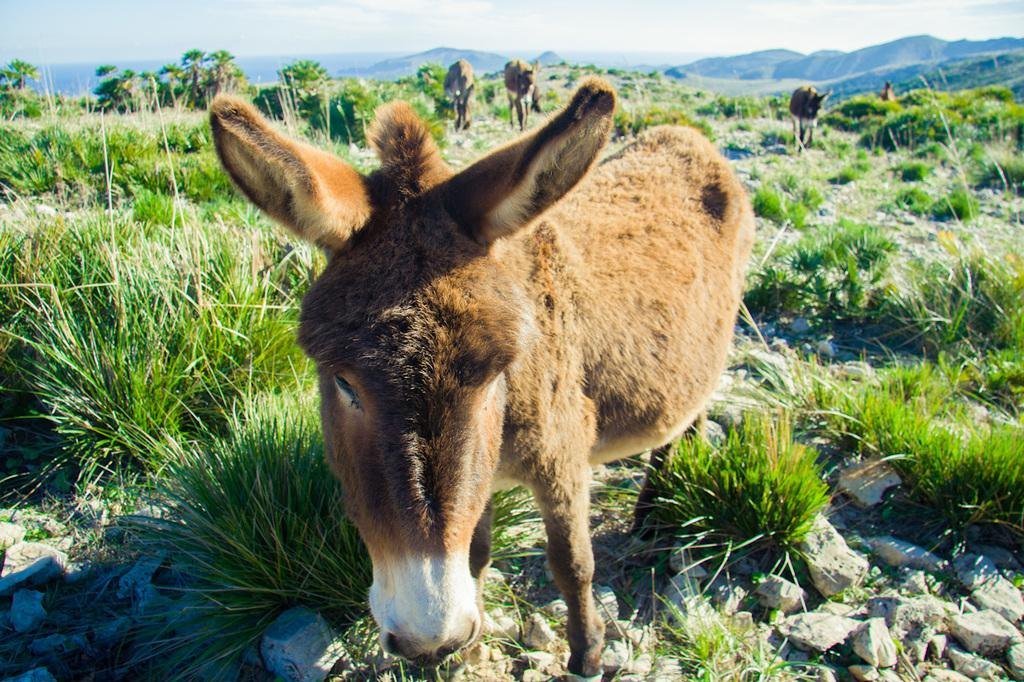What animals can be seen in the image? There are donkeys in the image. What type of vegetation is present in the image? There is grass in the image. What other objects can be seen on the ground in the image? There are stones in the image. What type of natural features are visible in the image? There are trees and hills visible in the image. What is visible in the background of the image? The sky is visible in the background of the image. Where is the baby's school located in the image? There is no baby or school present in the image. What type of plants can be seen growing on the hills in the image? There is no mention of plants growing on the hills in the image; only trees are mentioned. 